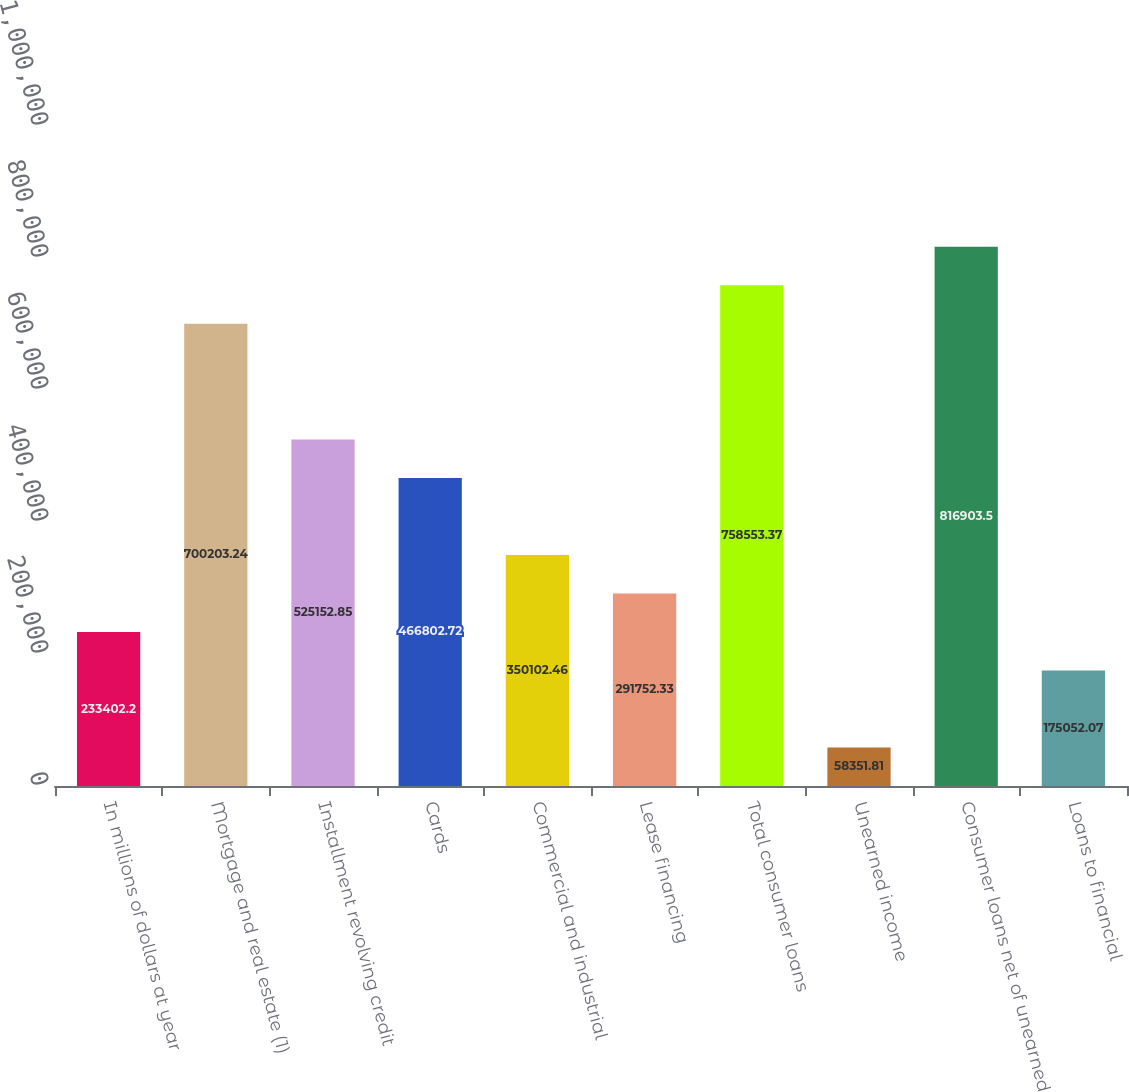Convert chart to OTSL. <chart><loc_0><loc_0><loc_500><loc_500><bar_chart><fcel>In millions of dollars at year<fcel>Mortgage and real estate (1)<fcel>Installment revolving credit<fcel>Cards<fcel>Commercial and industrial<fcel>Lease financing<fcel>Total consumer loans<fcel>Unearned income<fcel>Consumer loans net of unearned<fcel>Loans to financial<nl><fcel>233402<fcel>700203<fcel>525153<fcel>466803<fcel>350102<fcel>291752<fcel>758553<fcel>58351.8<fcel>816904<fcel>175052<nl></chart> 